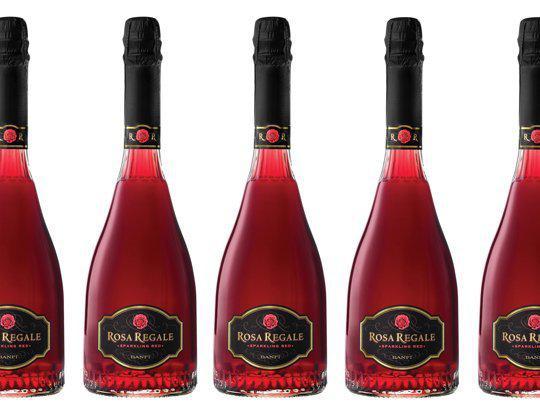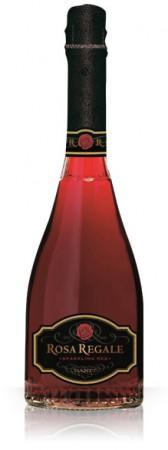The first image is the image on the left, the second image is the image on the right. Assess this claim about the two images: "One image shows only part of one wine glass and part of one bottle of wine.". Correct or not? Answer yes or no. No. The first image is the image on the left, the second image is the image on the right. Given the left and right images, does the statement "There are 2 bottles of wine standing upright." hold true? Answer yes or no. No. 